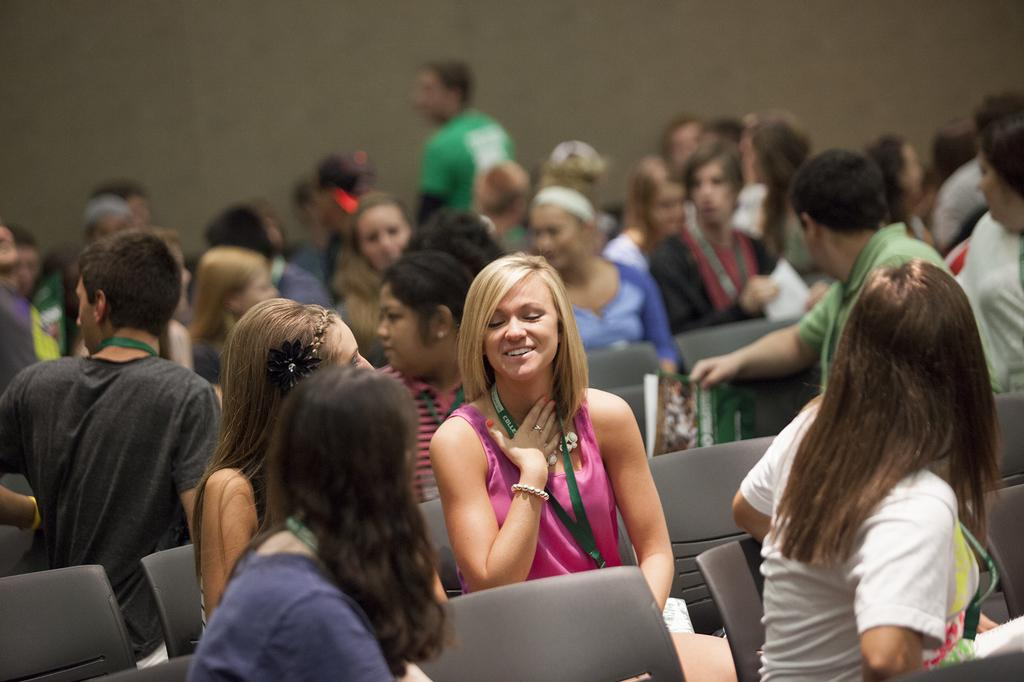What is happening in the image? There is a group of people in the image, and they are sitting on chairs. Can you describe the appearance of one of the women in the image? There is a woman wearing pink clothes in the image, and she is wearing an ID card. Who is sitting beside the woman in pink clothes? There is another woman beside the woman in pink clothes. What type of event is taking place at the harbor in the image? There is no harbor or event present in the image; it features a group of people sitting on chairs. Can you tell me the name of the judge sitting next to the woman in pink clothes? There is no judge present in the image, and the provided facts do not mention any names. 